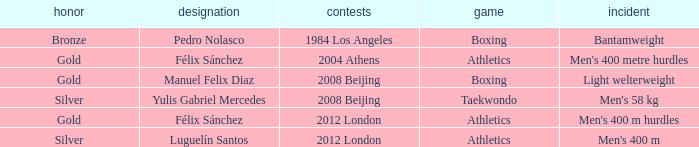Which Medal had a Name of félix sánchez, and a Games of 2012 london? Gold. 